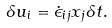Convert formula to latex. <formula><loc_0><loc_0><loc_500><loc_500>\delta u _ { i } = \dot { \epsilon } _ { i j } x _ { j } \delta t .</formula> 